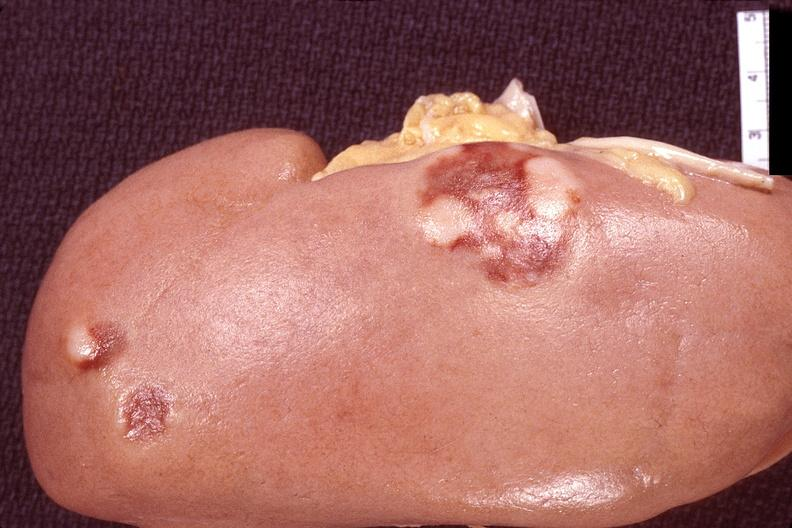does this image show kidney, lymphoma?
Answer the question using a single word or phrase. Yes 